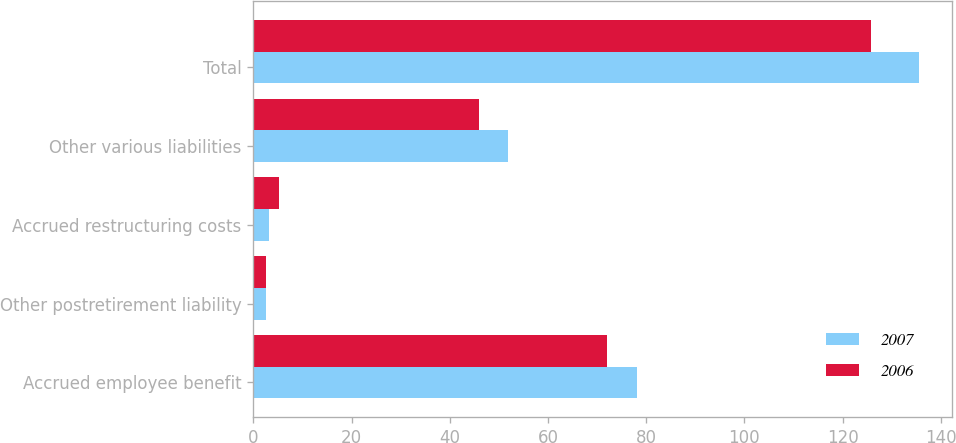<chart> <loc_0><loc_0><loc_500><loc_500><stacked_bar_chart><ecel><fcel>Accrued employee benefit<fcel>Other postretirement liability<fcel>Accrued restructuring costs<fcel>Other various liabilities<fcel>Total<nl><fcel>2007<fcel>78.1<fcel>2.5<fcel>3.2<fcel>51.8<fcel>135.6<nl><fcel>2006<fcel>72.1<fcel>2.5<fcel>5.3<fcel>45.9<fcel>125.8<nl></chart> 